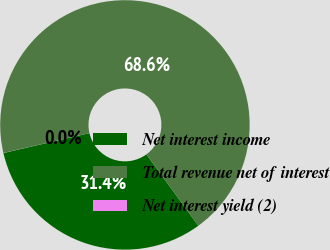Convert chart to OTSL. <chart><loc_0><loc_0><loc_500><loc_500><pie_chart><fcel>Net interest income<fcel>Total revenue net of interest<fcel>Net interest yield (2)<nl><fcel>31.39%<fcel>68.6%<fcel>0.01%<nl></chart> 